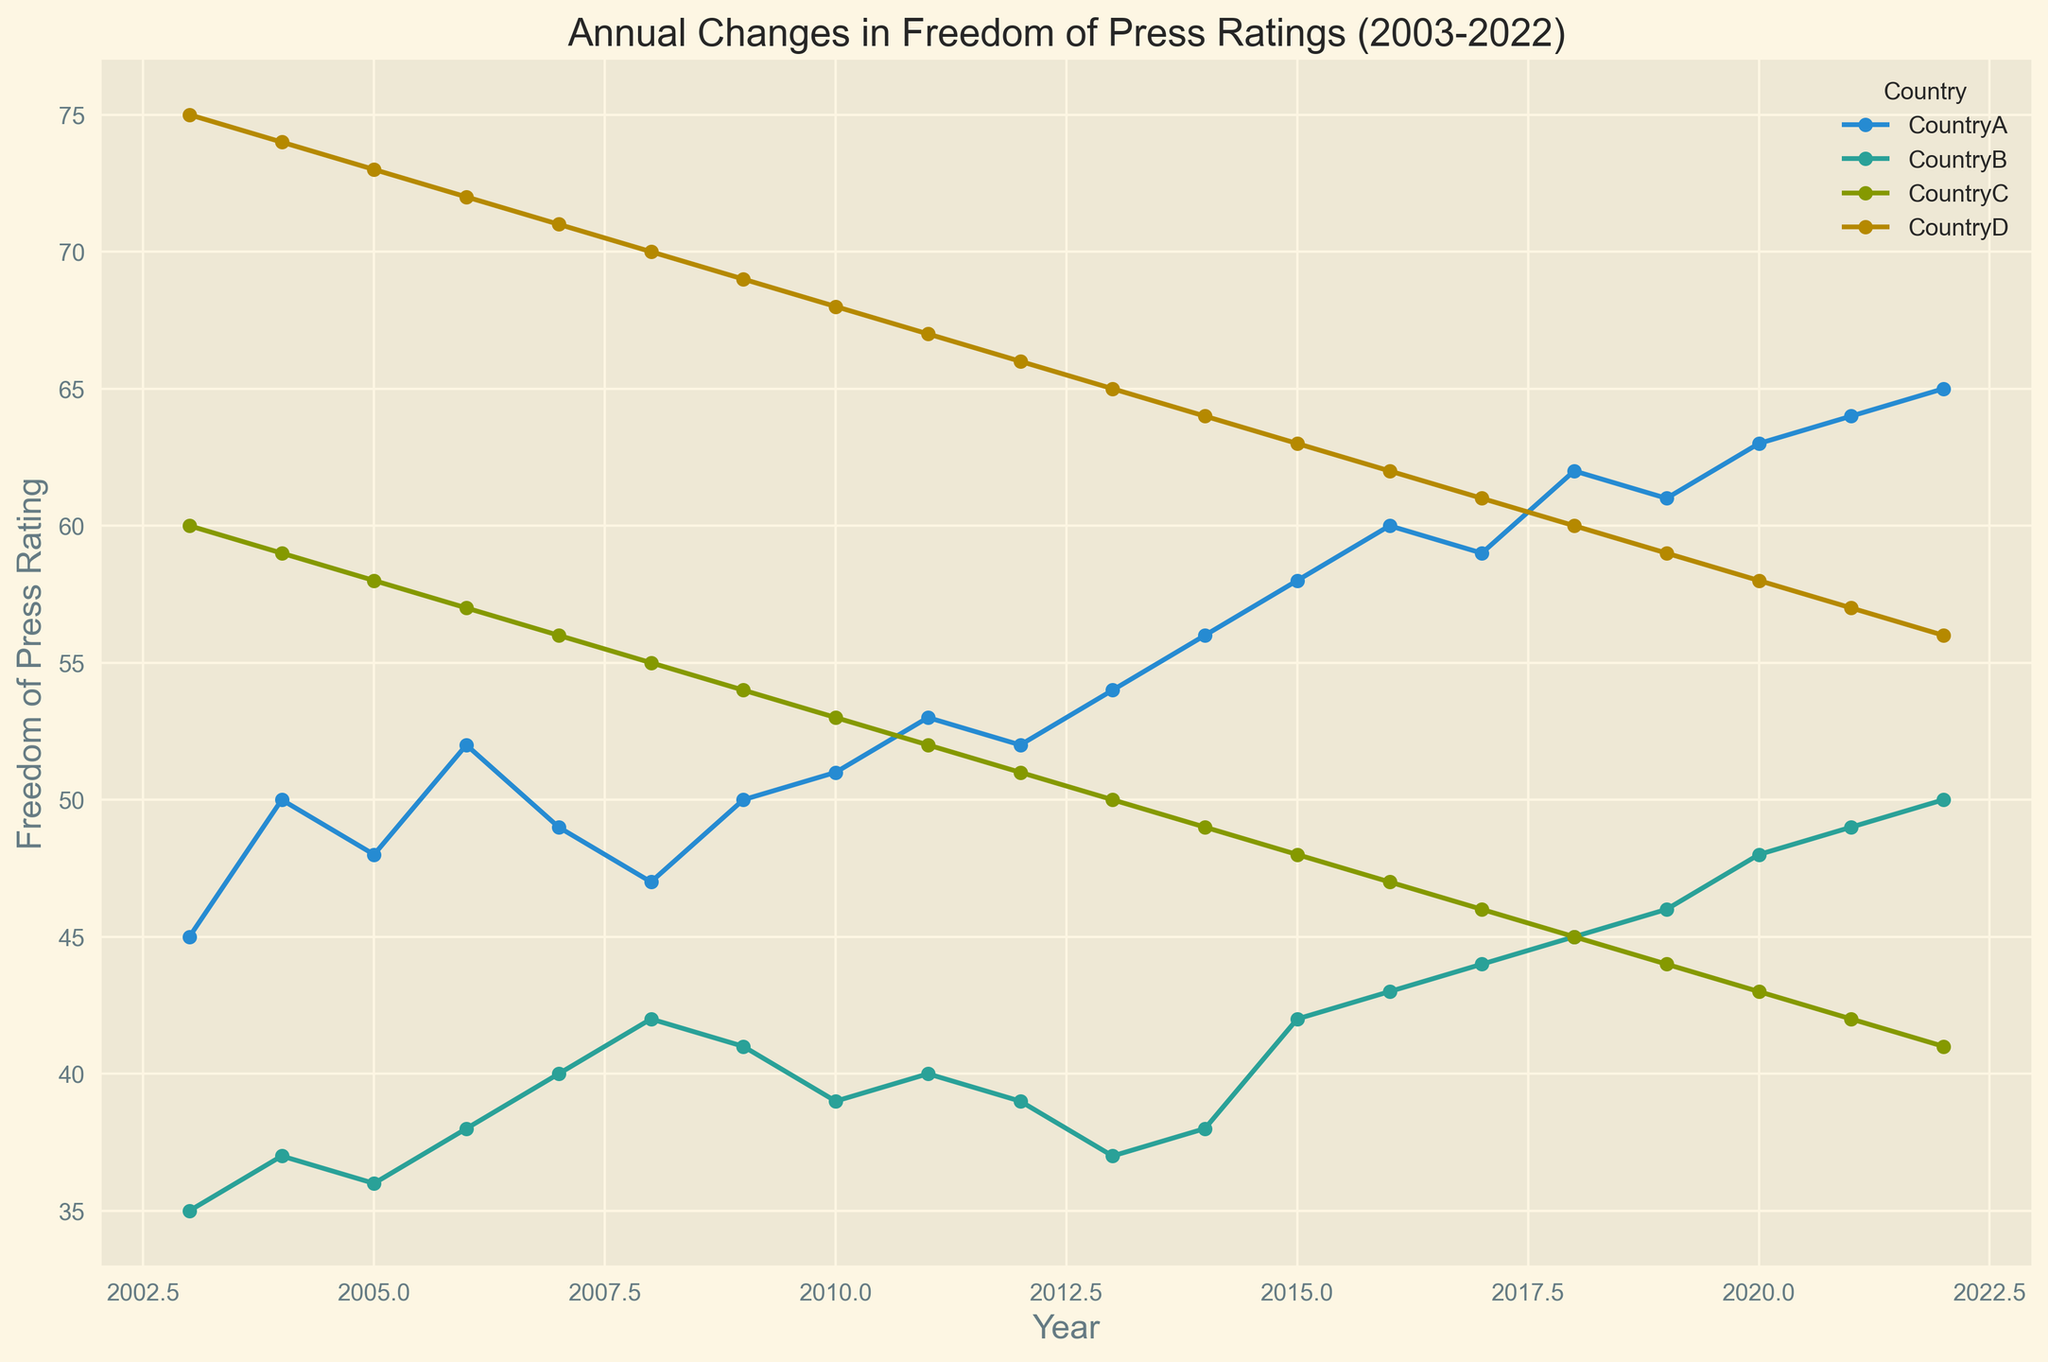What trend can be observed in CountryA's freedom of press rating from 2003 to 2022? From 2003 to 2022, the freedom of press rating for CountryA generally shows an upward trend, starting at 45 and gradually increasing to 65. This indicates a deterioration in press freedom over the two decades since higher ratings typically correlate with less press freedom.
Answer: Upward trend in press rating How does the freedom of press rating for CountryB in 2022 compare to that in 2003? In 2003, CountryB's rating was 35. By 2022, it increased to 50. This shows a noticeable increase, indicating worsening conditions for press freedom.
Answer: 50 compared to 35 Which country has shown the most consistent decline in freedom of press ratings over the periods shown in the chart? CountryC shows the most consistent decline in the freedom of press rating, starting at 60 in 2003 and decreasing steadily to 41 by 2022.
Answer: CountryC Between CountryA and CountryD, which one had a greater change in the freedom of press rating from 2003 to 2022? CountryA's rating increased from 45 to 65, a change of 20 points. CountryD's rating decreased from 75 to 56, a change of 19 points. Thus, CountryA saw a slightly greater change over the period.
Answer: CountryA What is the average freedom of press rating for CountryB over the 20-year period shown in the chart? To find the average, sum up all the ratings for CountryB and divide by the number of years. The sum of the ratings from 2003 to 2022 is 820. There are 20 years, so the average rating is 820/20 = 41.
Answer: 41 In which year did CountryD have the same freedom of press rating as CountryC? To find when CountryD and CountryC had the same rating, look at the intersecting point in the chart. Both countries had a rating of 56 in 2007.
Answer: 2007 Which country experienced the least change in press freedom rating from 2003 to 2022, and what was the change? CountryC experienced the least overall change, with a decrease from 60 in 2003 to 41 in 2022, a change of 19 points.
Answer: CountryC, 19 points Identify the year when CountryA and CountryB had the smallest difference in their freedom of press ratings. By examining the chart, the smallest difference occurred in 2005, where CountryA had a rating of 48 and CountryB had a rating of 36, resulting in a difference of 12.
Answer: 2005 Which country consistently improved its freedom of press rating from 2003 to 2022? CountryD consistently improved its freedom of press rating each year from 2003 (75) to 2022 (56), reflecting better press freedom conditions.
Answer: CountryD 